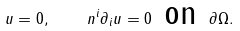Convert formula to latex. <formula><loc_0><loc_0><loc_500><loc_500>u = 0 , \quad n ^ { i } \partial _ { i } u = 0 \text { on } \partial \Omega .</formula> 